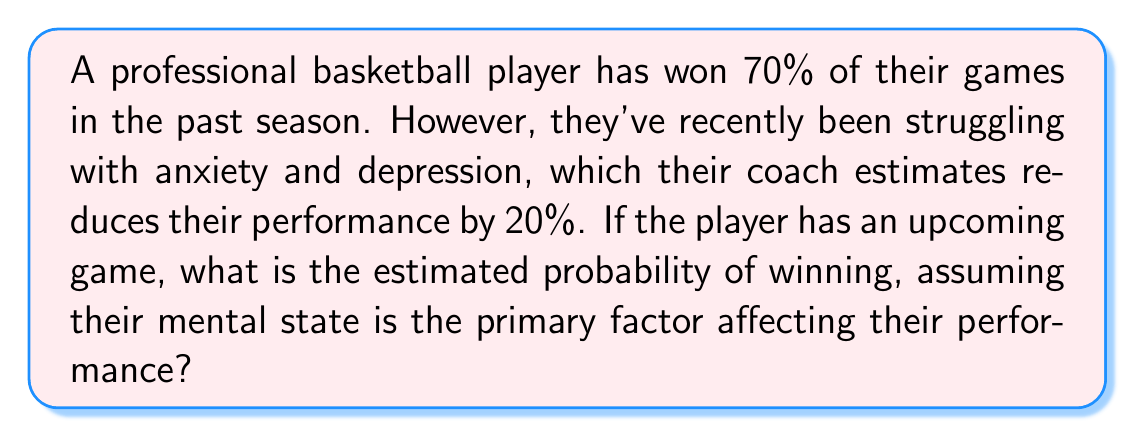Teach me how to tackle this problem. To solve this problem, we'll use Bayesian reasoning to update our prior probability based on new information. Let's break it down step-by-step:

1. Prior probability:
   The player's past performance gives us a prior probability of winning:
   $P(\text{Win}) = 0.70$ or 70%

2. Impact of mental state:
   The coach estimates a 20% reduction in performance. We can interpret this as reducing the probability of winning by 20% of its current value.

3. Calculating the new probability:
   Let's call the new probability of winning $P(\text{Win}|\text{Mental State})$
   
   $$P(\text{Win}|\text{Mental State}) = P(\text{Win}) - (0.20 \times P(\text{Win}))$$
   
   $$P(\text{Win}|\text{Mental State}) = 0.70 - (0.20 \times 0.70)$$
   
   $$P(\text{Win}|\text{Mental State}) = 0.70 - 0.14$$
   
   $$P(\text{Win}|\text{Mental State}) = 0.56$$

4. Converting to percentage:
   0.56 × 100% = 56%

Therefore, the estimated probability of winning the upcoming game, taking into account the player's current mental state, is 56%.
Answer: 56% 